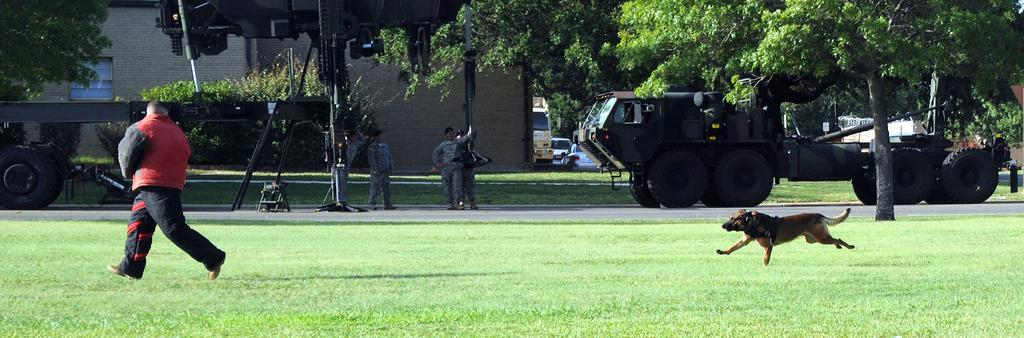What is the dog doing in the image? The dog is running on the grass at the right side of the image. What is the man doing in the image? The man is running at the left side of the image. How many people are present in the image? There are people present in the image. What can be seen on the road in the image? There are vehicles on the road in the image. What is visible in the background of the image? There are trees and buildings visible in the background of the image. What type of hole can be seen in the image? There is no hole present in the image. What is the source of power for the vehicles in the image? The image does not provide information about the source of power for the vehicles. 